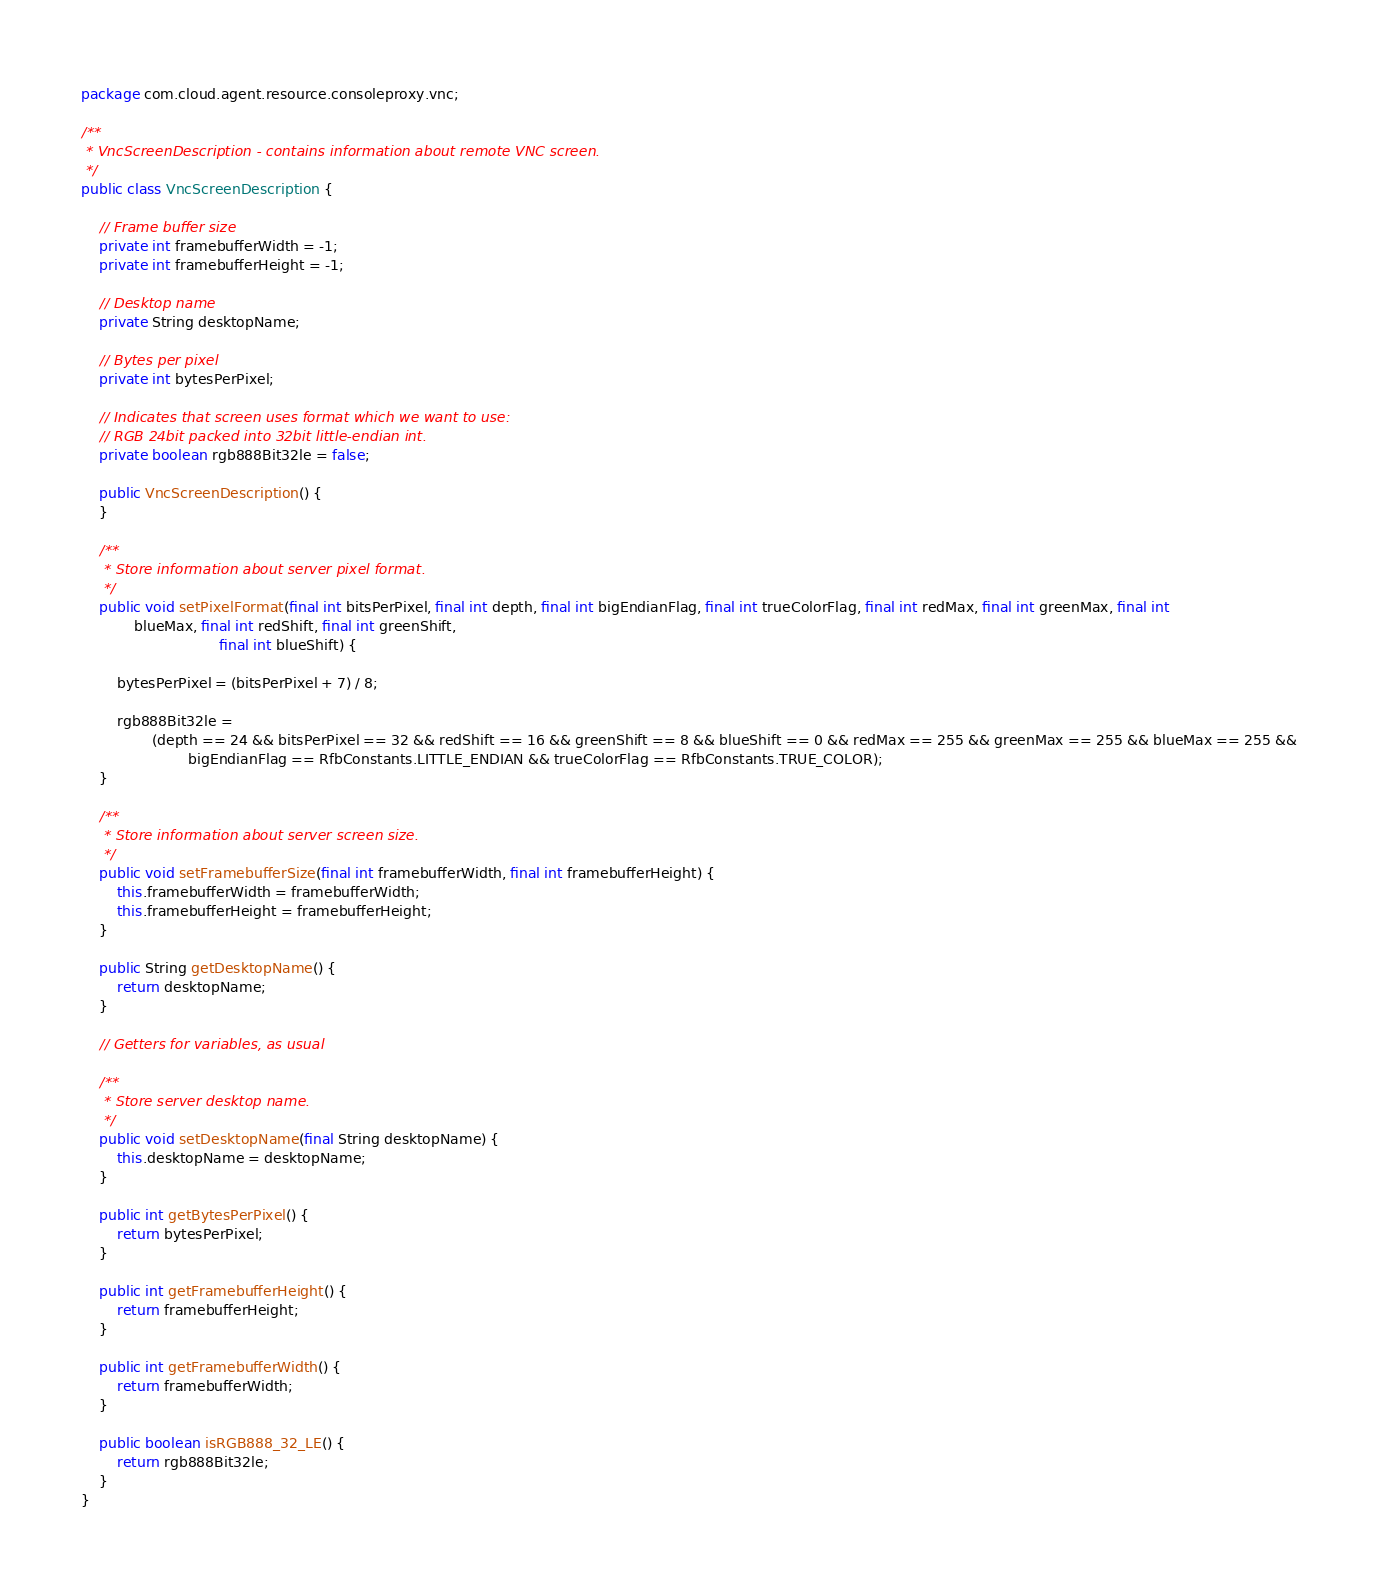<code> <loc_0><loc_0><loc_500><loc_500><_Java_>package com.cloud.agent.resource.consoleproxy.vnc;

/**
 * VncScreenDescription - contains information about remote VNC screen.
 */
public class VncScreenDescription {

    // Frame buffer size
    private int framebufferWidth = -1;
    private int framebufferHeight = -1;

    // Desktop name
    private String desktopName;

    // Bytes per pixel
    private int bytesPerPixel;

    // Indicates that screen uses format which we want to use:
    // RGB 24bit packed into 32bit little-endian int.
    private boolean rgb888Bit32le = false;

    public VncScreenDescription() {
    }

    /**
     * Store information about server pixel format.
     */
    public void setPixelFormat(final int bitsPerPixel, final int depth, final int bigEndianFlag, final int trueColorFlag, final int redMax, final int greenMax, final int
            blueMax, final int redShift, final int greenShift,
                               final int blueShift) {

        bytesPerPixel = (bitsPerPixel + 7) / 8;

        rgb888Bit32le =
                (depth == 24 && bitsPerPixel == 32 && redShift == 16 && greenShift == 8 && blueShift == 0 && redMax == 255 && greenMax == 255 && blueMax == 255 &&
                        bigEndianFlag == RfbConstants.LITTLE_ENDIAN && trueColorFlag == RfbConstants.TRUE_COLOR);
    }

    /**
     * Store information about server screen size.
     */
    public void setFramebufferSize(final int framebufferWidth, final int framebufferHeight) {
        this.framebufferWidth = framebufferWidth;
        this.framebufferHeight = framebufferHeight;
    }

    public String getDesktopName() {
        return desktopName;
    }

    // Getters for variables, as usual

    /**
     * Store server desktop name.
     */
    public void setDesktopName(final String desktopName) {
        this.desktopName = desktopName;
    }

    public int getBytesPerPixel() {
        return bytesPerPixel;
    }

    public int getFramebufferHeight() {
        return framebufferHeight;
    }

    public int getFramebufferWidth() {
        return framebufferWidth;
    }

    public boolean isRGB888_32_LE() {
        return rgb888Bit32le;
    }
}
</code> 